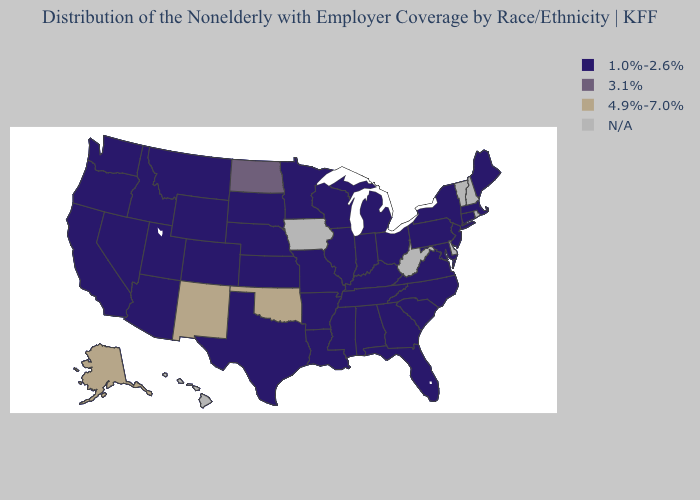What is the value of Kansas?
Give a very brief answer. 1.0%-2.6%. Name the states that have a value in the range 3.1%?
Give a very brief answer. North Dakota. Among the states that border Ohio , which have the highest value?
Be succinct. Indiana, Kentucky, Michigan, Pennsylvania. What is the highest value in the USA?
Answer briefly. 4.9%-7.0%. Does the map have missing data?
Keep it brief. Yes. Among the states that border Colorado , which have the highest value?
Concise answer only. New Mexico, Oklahoma. What is the highest value in the West ?
Concise answer only. 4.9%-7.0%. Does the map have missing data?
Short answer required. Yes. What is the value of South Carolina?
Keep it brief. 1.0%-2.6%. What is the highest value in states that border Maryland?
Concise answer only. 1.0%-2.6%. Which states have the lowest value in the USA?
Write a very short answer. Alabama, Arizona, Arkansas, California, Colorado, Connecticut, Florida, Georgia, Idaho, Illinois, Indiana, Kansas, Kentucky, Louisiana, Maine, Maryland, Massachusetts, Michigan, Minnesota, Mississippi, Missouri, Montana, Nebraska, Nevada, New Jersey, New York, North Carolina, Ohio, Oregon, Pennsylvania, South Carolina, South Dakota, Tennessee, Texas, Utah, Virginia, Washington, Wisconsin, Wyoming. Does the map have missing data?
Short answer required. Yes. Does Oklahoma have the lowest value in the South?
Concise answer only. No. Does Alaska have the lowest value in the USA?
Concise answer only. No. 